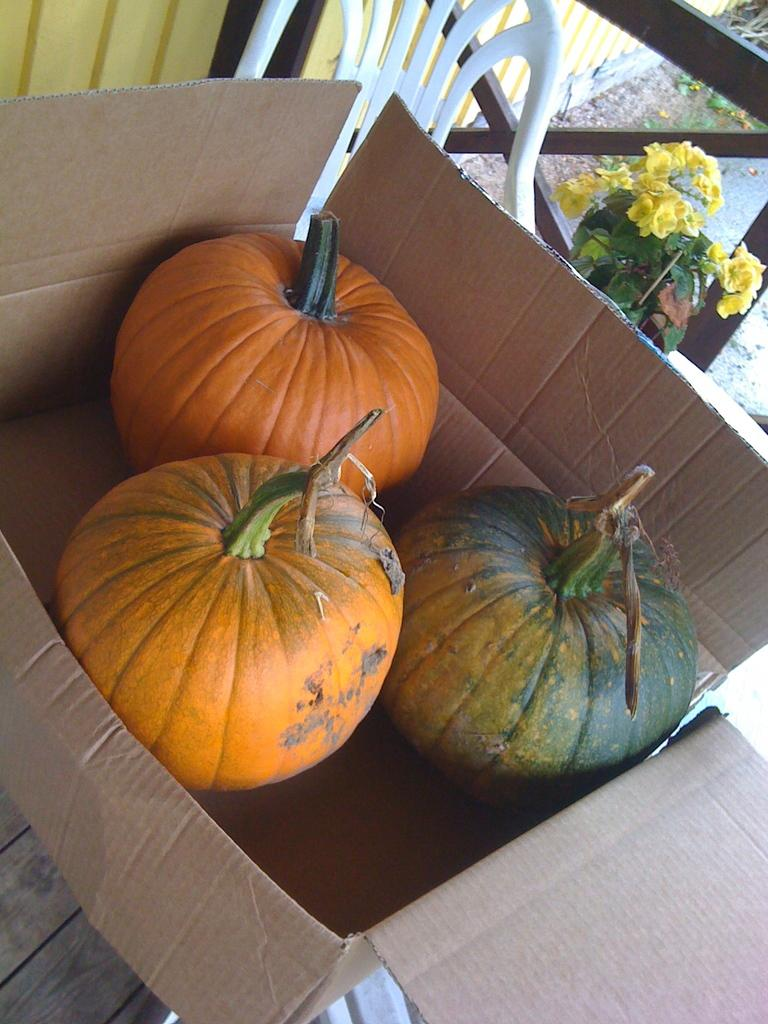What is placed in the box on the table in the image? There are pumpkins in the box on the table in the image. What can be seen in the background of the image? There is a chair in the background of the image. What type of plant is visible in the image? There is a flower plant in the image. What is the structure made of that is visible in the image? The wooden grill in the image is made of wood. What is the backdrop of the scene in the image? There is a wall in the image. What type of toe is the actor using to grill the pumpkins in the image? There is no actor or toe present in the image, and pumpkins are not being grilled. 